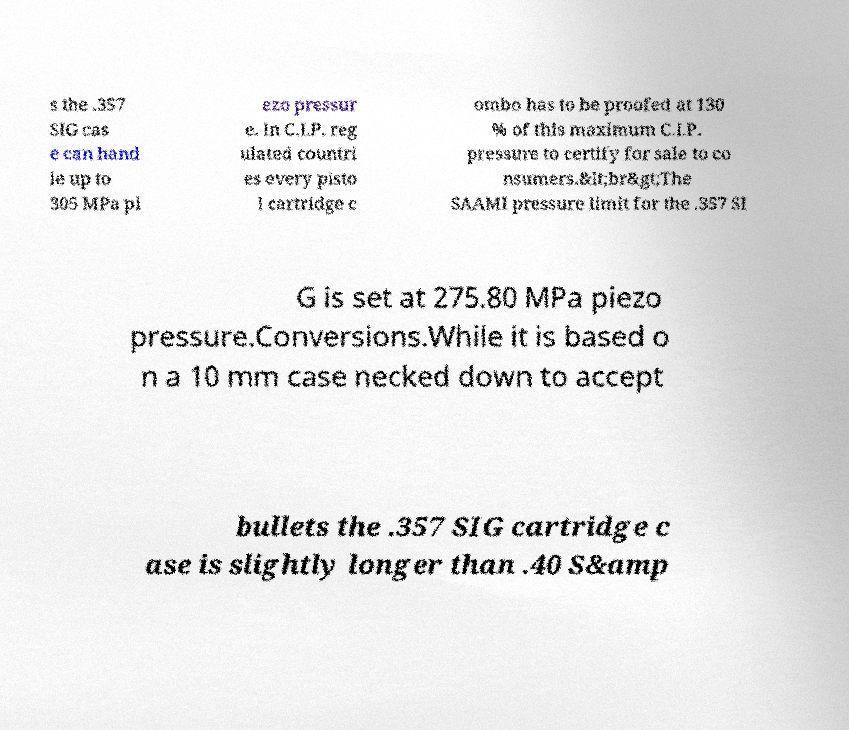For documentation purposes, I need the text within this image transcribed. Could you provide that? s the .357 SIG cas e can hand le up to 305 MPa pi ezo pressur e. In C.I.P. reg ulated countri es every pisto l cartridge c ombo has to be proofed at 130 % of this maximum C.I.P. pressure to certify for sale to co nsumers.&lt;br&gt;The SAAMI pressure limit for the .357 SI G is set at 275.80 MPa piezo pressure.Conversions.While it is based o n a 10 mm case necked down to accept bullets the .357 SIG cartridge c ase is slightly longer than .40 S&amp 